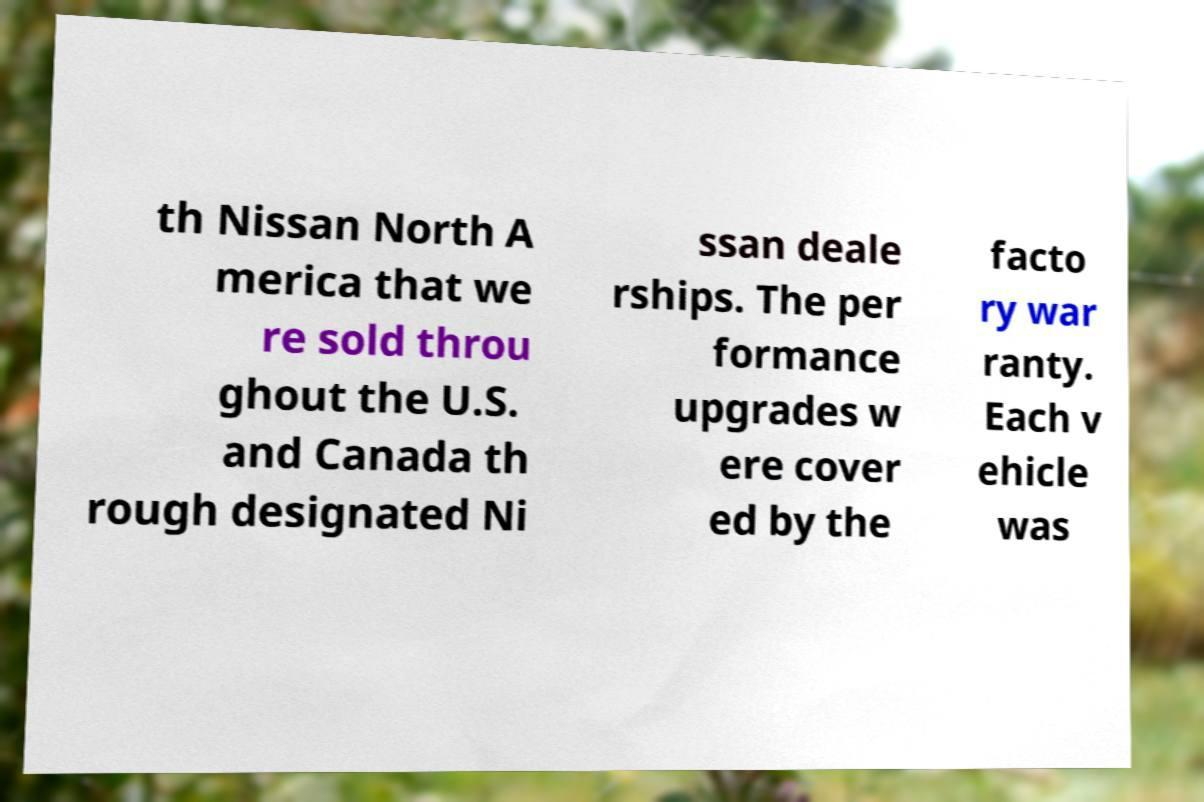I need the written content from this picture converted into text. Can you do that? th Nissan North A merica that we re sold throu ghout the U.S. and Canada th rough designated Ni ssan deale rships. The per formance upgrades w ere cover ed by the facto ry war ranty. Each v ehicle was 